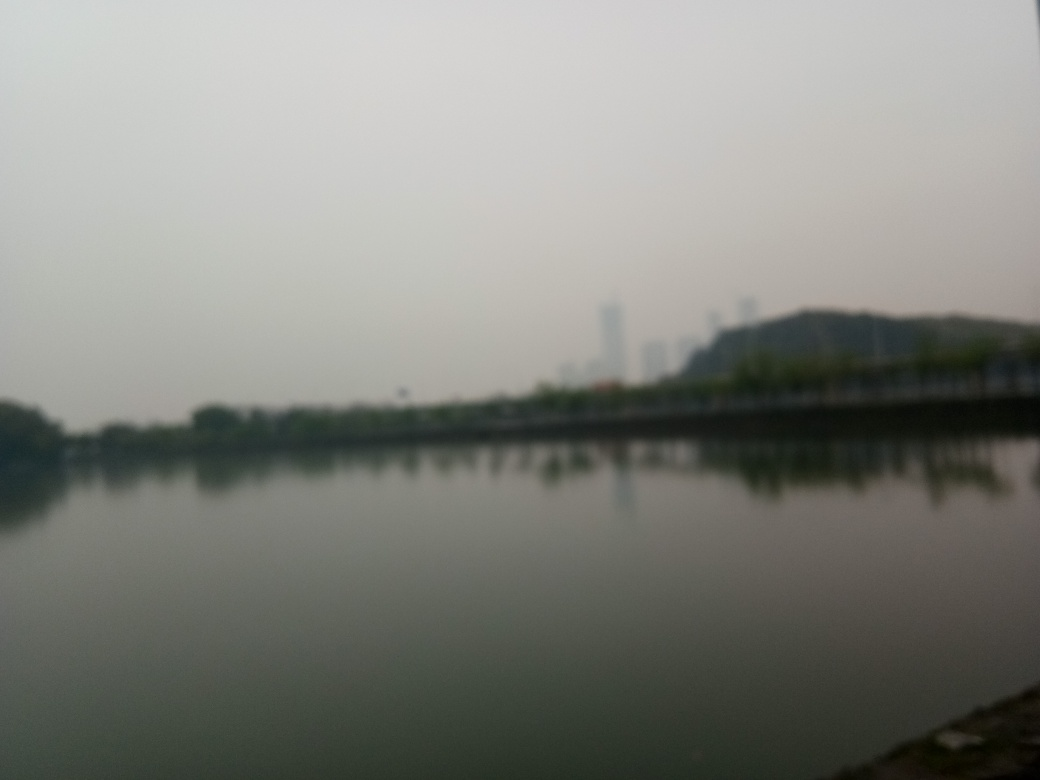Can you describe the weather in the image? The weather appears overcast, with a uniformly grey sky that diffuses the light evenly, but there is no clear evidence of precipitation. Such conditions often result in subdued colors and low contrast in photographs. 